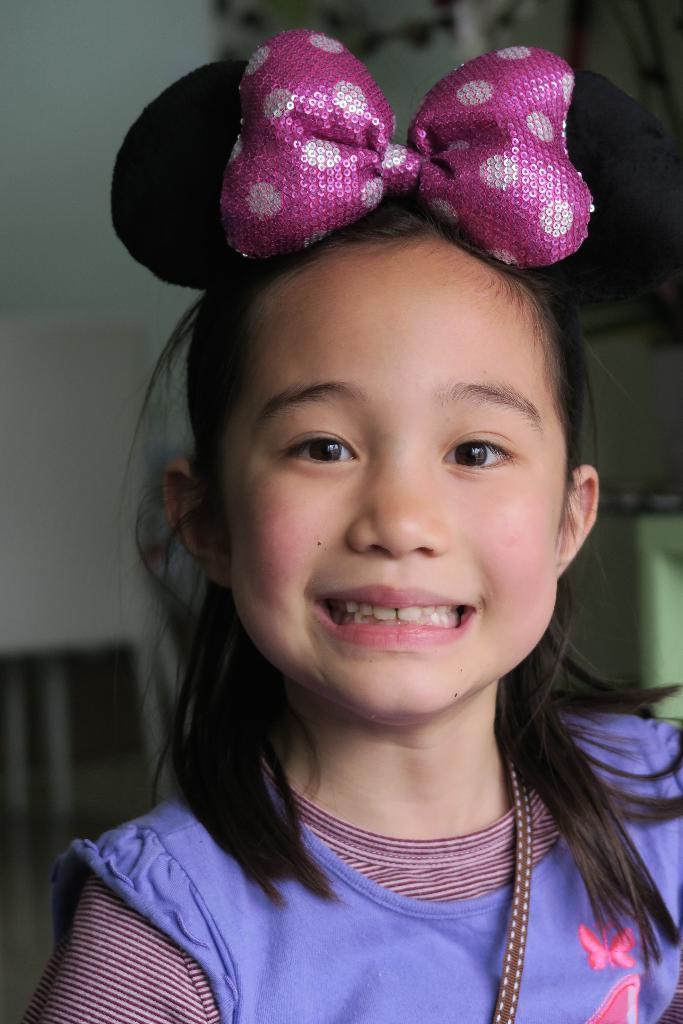How would you summarize this image in a sentence or two? This picture shows a girl with a smile on her face. 